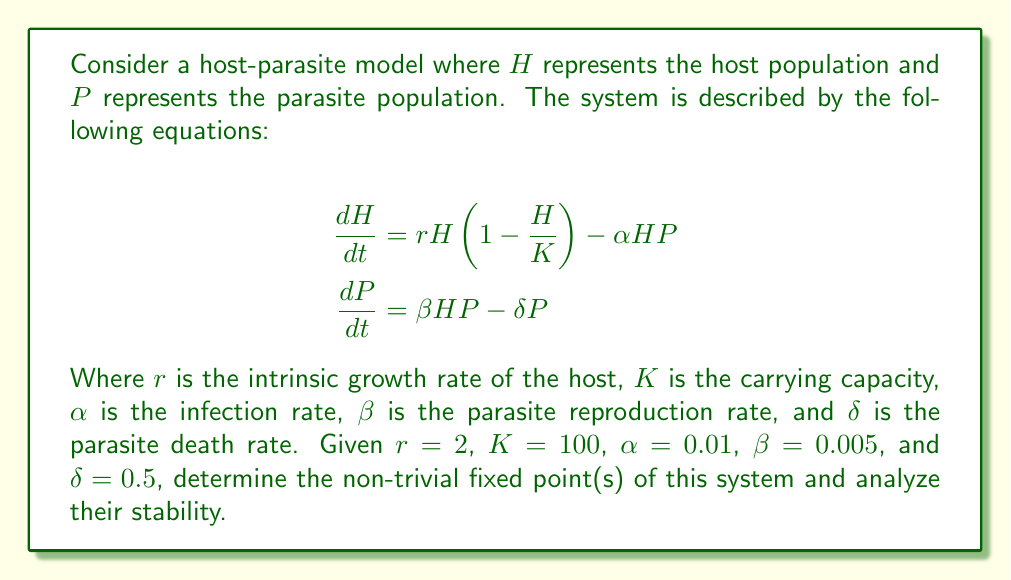What is the answer to this math problem? To solve this problem, we'll follow these steps:

1) Find the fixed points by setting $\frac{dH}{dt} = 0$ and $\frac{dP}{dt} = 0$.

2) Solve the resulting system of equations.

3) Analyze the stability of the non-trivial fixed point(s) using the Jacobian matrix.

Step 1: Setting the equations to zero:

$$0 = rH(1-\frac{H}{K}) - \alpha HP$$
$$0 = \beta HP - \delta P$$

Step 2: Solving the system:

From the second equation: $P = 0$ or $H = \frac{\delta}{\beta}$

If $P = 0$, then from the first equation: $H = 0$ or $H = K$

These give us the trivial fixed points $(0,0)$ and $(K,0)$

For the non-trivial fixed point, substitute $H = \frac{\delta}{\beta}$ into the first equation:

$$0 = r\frac{\delta}{\beta}(1-\frac{\delta}{\beta K}) - \alpha \frac{\delta}{\beta}P$$

Solving for $P$:

$$P = \frac{r}{\alpha}(1-\frac{\delta}{\beta K})$$

Therefore, the non-trivial fixed point is $(\frac{\delta}{\beta}, \frac{r}{\alpha}(1-\frac{\delta}{\beta K}))$

With the given values: $(\frac{0.5}{0.005}, \frac{2}{0.01}(1-\frac{0.5}{0.005 \cdot 100})) = (100, 150)$

Step 3: Stability analysis:

The Jacobian matrix is:

$$J = \begin{bmatrix}
r(1-\frac{2H}{K}) - \alpha P & -\alpha H \\
\beta P & \beta H - \delta
\end{bmatrix}$$

At the fixed point $(100, 150)$:

$$J = \begin{bmatrix}
2(1-\frac{2 \cdot 100}{100}) - 0.01 \cdot 150 & -0.01 \cdot 100 \\
0.005 \cdot 150 & 0.005 \cdot 100 - 0.5
\end{bmatrix}$$

$$J = \begin{bmatrix}
-3.5 & -1 \\
0.75 & 0
\end{bmatrix}$$

The eigenvalues of this matrix are:
$\lambda_1 \approx -3.6839$ and $\lambda_2 \approx 0.1839$

Since one eigenvalue is positive and one is negative, this fixed point is a saddle point and is unstable.
Answer: Non-trivial fixed point: $(100, 150)$. Unstable saddle point. 